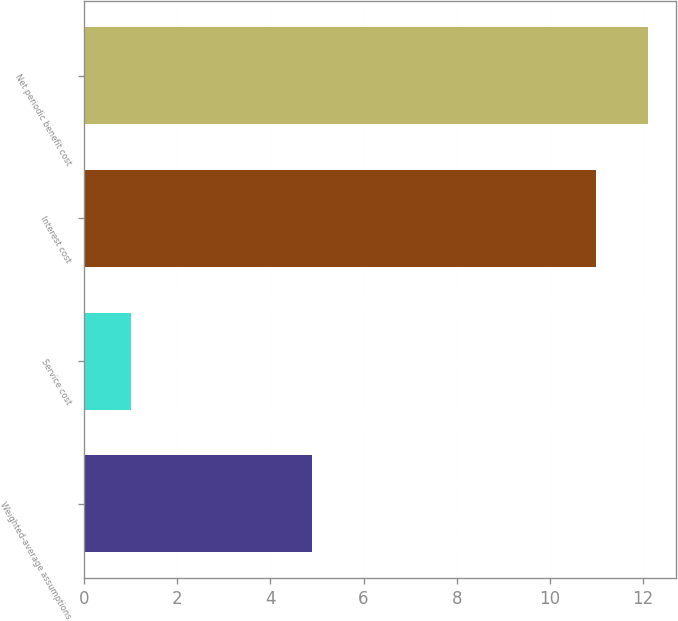<chart> <loc_0><loc_0><loc_500><loc_500><bar_chart><fcel>Weighted-average assumptions<fcel>Service cost<fcel>Interest cost<fcel>Net periodic benefit cost<nl><fcel>4.9<fcel>1<fcel>11<fcel>12.1<nl></chart> 